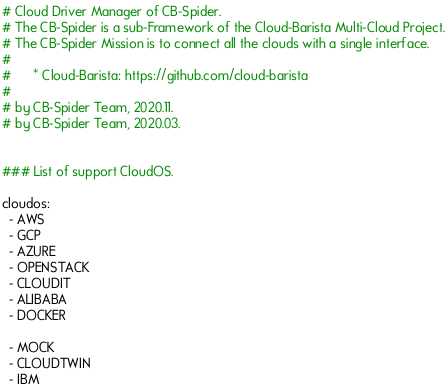<code> <loc_0><loc_0><loc_500><loc_500><_YAML_># Cloud Driver Manager of CB-Spider.
# The CB-Spider is a sub-Framework of the Cloud-Barista Multi-Cloud Project.
# The CB-Spider Mission is to connect all the clouds with a single interface.
#
#      * Cloud-Barista: https://github.com/cloud-barista
#
# by CB-Spider Team, 2020.11.
# by CB-Spider Team, 2020.03.


### List of support CloudOS.

cloudos:
  - AWS
  - GCP
  - AZURE
  - OPENSTACK
  - CLOUDIT
  - ALIBABA
  - DOCKER

  - MOCK
  - CLOUDTWIN
  - IBM
</code> 